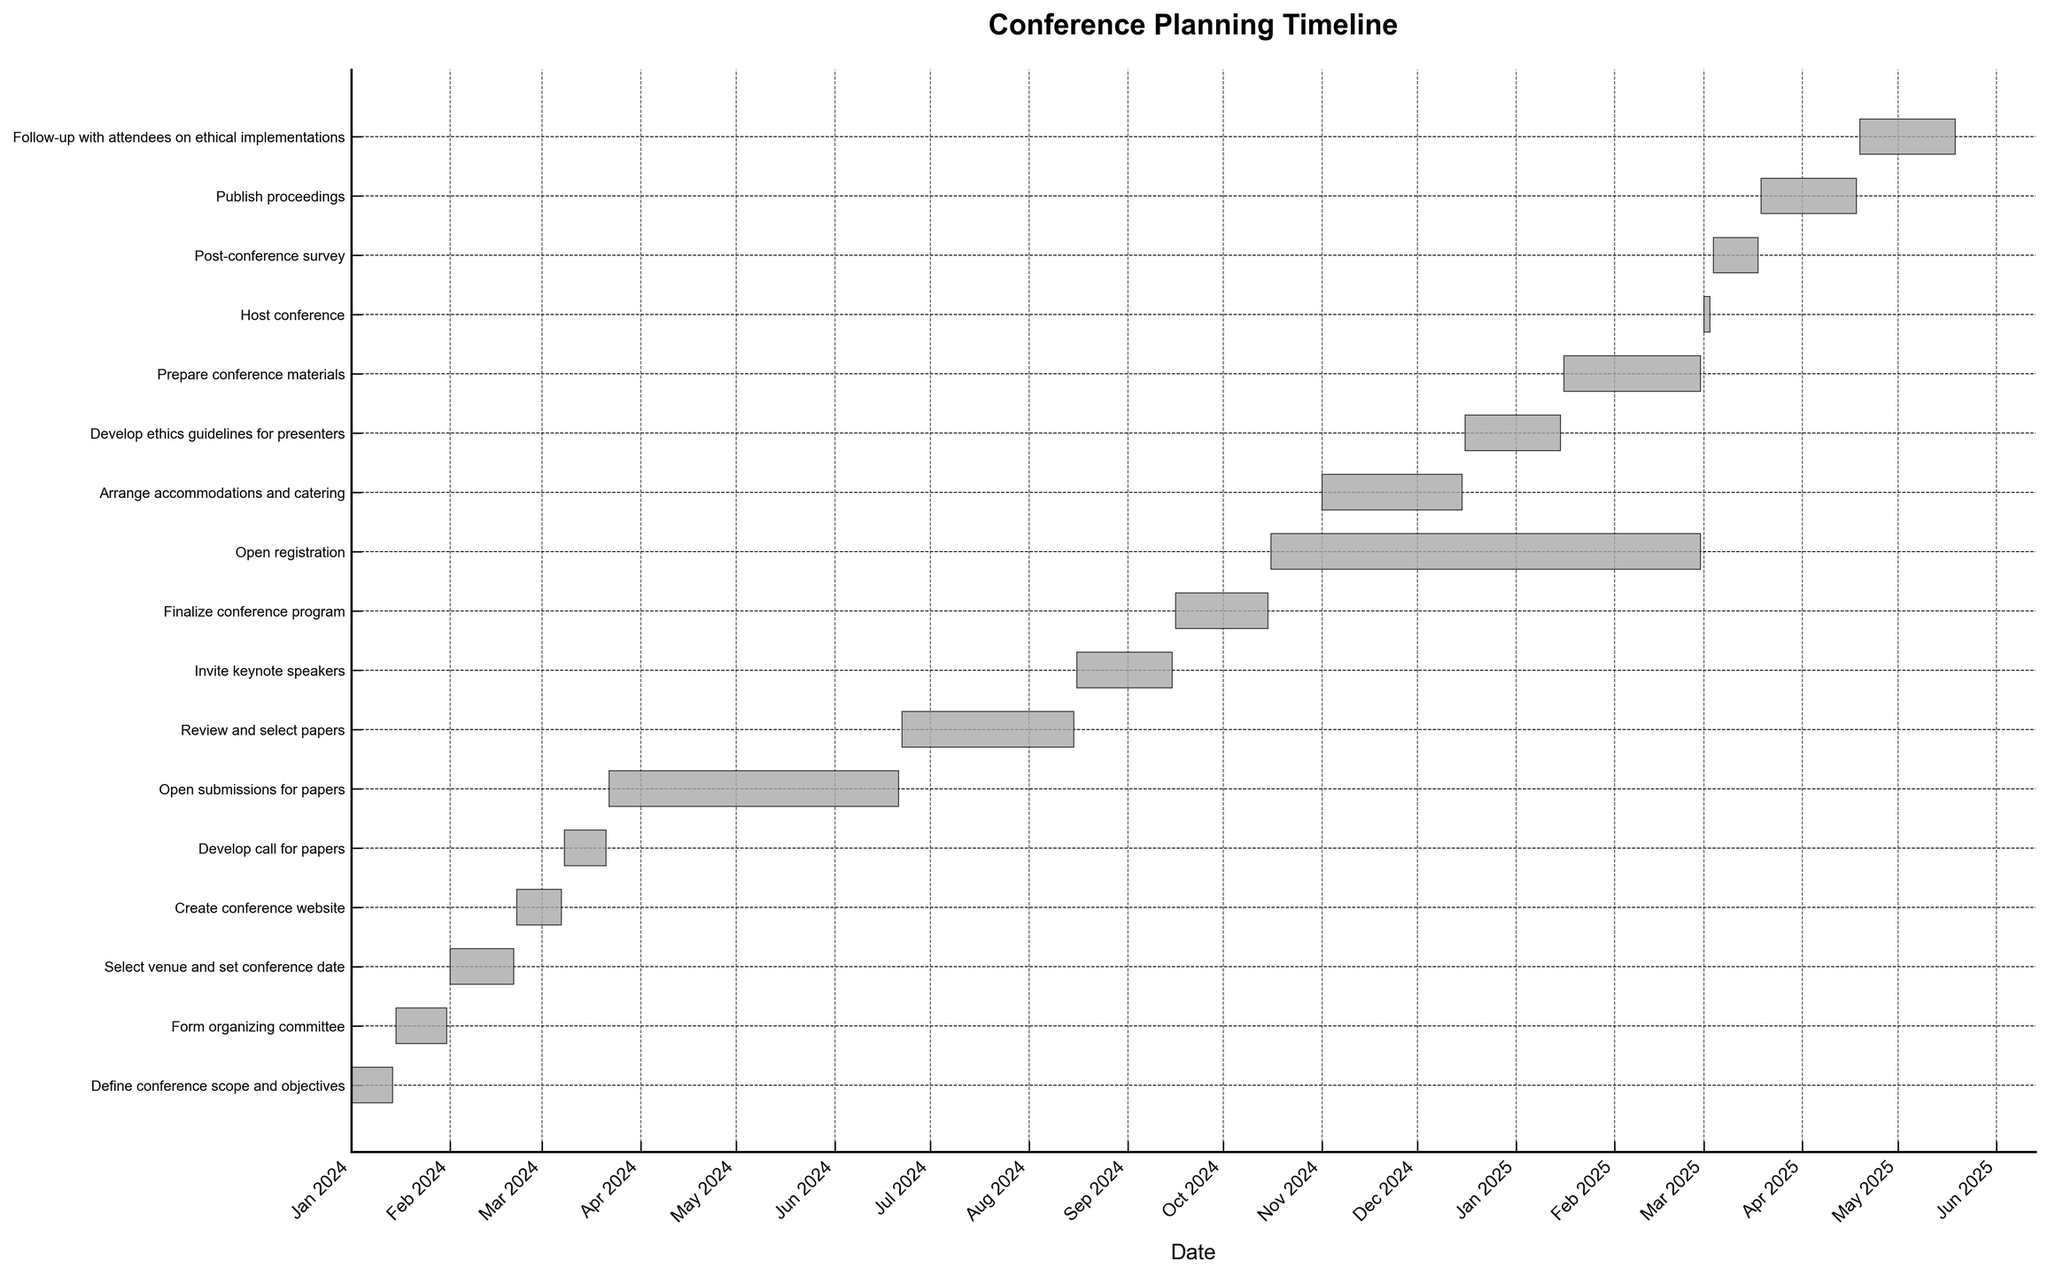What is the title of the Gantt chart? The title of the Gantt chart is located at the top of the figure and it usually gives a brief overview of what the chart represents. In this case, the title is displayed as "Conference Planning Timeline".
Answer: Conference Planning Timeline When does the task "Invite keynote speakers" end? You can locate the task "Invite keynote speakers" on the vertical axis and follow the corresponding horizontal bar to the end. According to the chart, the task ends in September 2024.
Answer: September 2024 Which task has the longest duration? To find the task with the longest duration, compare the lengths of all the horizontal bars. The task "Open registration" has the longest bar, indicating the longest duration, starting in October 2024 and ending in February 2025.
Answer: Open registration How many tasks are scheduled to end by the end of 2024? Review the end dates of all the horizontal bars. Tasks ending by December 31, 2024, are counted. Tasks that end by the end of 2024 are: "Define conference scope and objectives", "Form organizing committee", "Select venue and set conference date", "Create conference website", "Develop call for papers", "Open submissions for papers", "Review and select papers", "Invite keynote speakers", and "Arrange accommodations and catering". There are 9 tasks.
Answer: 9 What is the duration of the task "Develop ethics guidelines for presenters"? The duration can be calculated by determining the time span between the start and end dates. The task starts in December 2024 and ends in January 2025. This is approximately 1 month.
Answer: Approximately 1 month Which task occurs directly before "Host conference"? The task "Prepare conference materials" ends just before the start of "Host conference". To identify this, look at the task bars that overlap near the start of March 2025.
Answer: Prepare conference materials Explain the overlap between "Finalize conference program" and "Arrange accommodations and catering". To explain overlaps, assess the tasks on the y-axis and view if their bars overlap horizontally. "Finalize conference program" starts in September 2024 and ends in October 2024. In contrast, "Arrange accommodations and catering" spans from November 2024 to December 2024. Since "Finalize conference program" ends before the start of "Arrange accommodations and catering", there’s no direct overlap between these two tasks.
Answer: No direct overlap When should the "Follow-up with attendees on ethical implementations" be completed? Check the end date of the task "Follow-up with attendees on ethical implementations". According to the chart, it should be completed by May 2025.
Answer: May 2025 